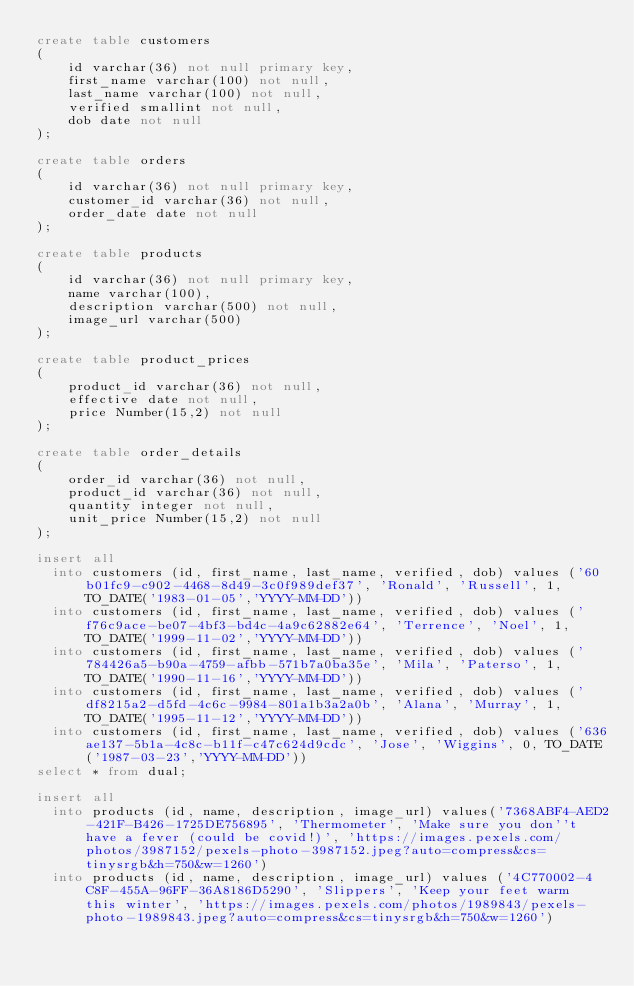Convert code to text. <code><loc_0><loc_0><loc_500><loc_500><_SQL_>create table customers
(
    id varchar(36) not null primary key,
    first_name varchar(100) not null,
    last_name varchar(100) not null,
    verified smallint not null,
    dob date not null
);

create table orders
(
    id varchar(36) not null primary key,
    customer_id varchar(36) not null,
    order_date date not null
);

create table products
(
    id varchar(36) not null primary key,
    name varchar(100),
    description varchar(500) not null,
    image_url varchar(500)
);

create table product_prices
(
    product_id varchar(36) not null,
    effective date not null,
    price Number(15,2) not null
);

create table order_details
(
    order_id varchar(36) not null,
    product_id varchar(36) not null,
    quantity integer not null,
    unit_price Number(15,2) not null
);

insert all 
	into customers (id, first_name, last_name, verified, dob) values ('60b01fc9-c902-4468-8d49-3c0f989def37', 'Ronald', 'Russell', 1, TO_DATE('1983-01-05','YYYY-MM-DD'))   
	into customers (id, first_name, last_name, verified, dob) values ('f76c9ace-be07-4bf3-bd4c-4a9c62882e64', 'Terrence', 'Noel', 1, TO_DATE('1999-11-02','YYYY-MM-DD'))
	into customers (id, first_name, last_name, verified, dob) values ('784426a5-b90a-4759-afbb-571b7a0ba35e', 'Mila', 'Paterso', 1, TO_DATE('1990-11-16','YYYY-MM-DD'))
	into customers (id, first_name, last_name, verified, dob) values ('df8215a2-d5fd-4c6c-9984-801a1b3a2a0b', 'Alana', 'Murray', 1, TO_DATE('1995-11-12','YYYY-MM-DD'))
	into customers (id, first_name, last_name, verified, dob) values ('636ae137-5b1a-4c8c-b11f-c47c624d9cdc', 'Jose', 'Wiggins', 0, TO_DATE('1987-03-23','YYYY-MM-DD'))
select * from dual;

insert all
	into products (id, name, description, image_url) values('7368ABF4-AED2-421F-B426-1725DE756895', 'Thermometer', 'Make sure you don''t have a fever (could be covid!)', 'https://images.pexels.com/photos/3987152/pexels-photo-3987152.jpeg?auto=compress&cs=tinysrgb&h=750&w=1260')
	into products (id, name, description, image_url) values ('4C770002-4C8F-455A-96FF-36A8186D5290', 'Slippers', 'Keep your feet warm this winter', 'https://images.pexels.com/photos/1989843/pexels-photo-1989843.jpeg?auto=compress&cs=tinysrgb&h=750&w=1260')</code> 